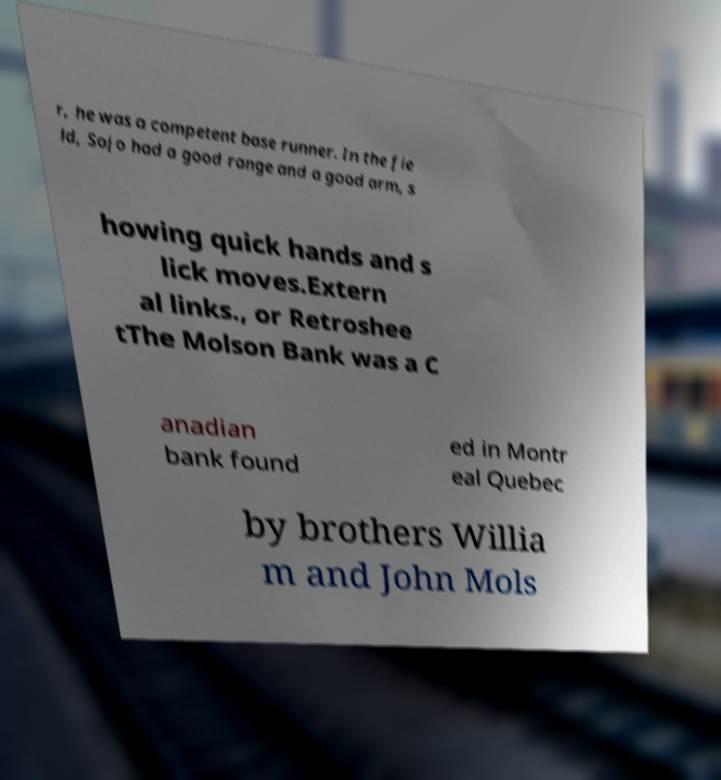What messages or text are displayed in this image? I need them in a readable, typed format. r, he was a competent base runner. In the fie ld, Sojo had a good range and a good arm, s howing quick hands and s lick moves.Extern al links., or Retroshee tThe Molson Bank was a C anadian bank found ed in Montr eal Quebec by brothers Willia m and John Mols 